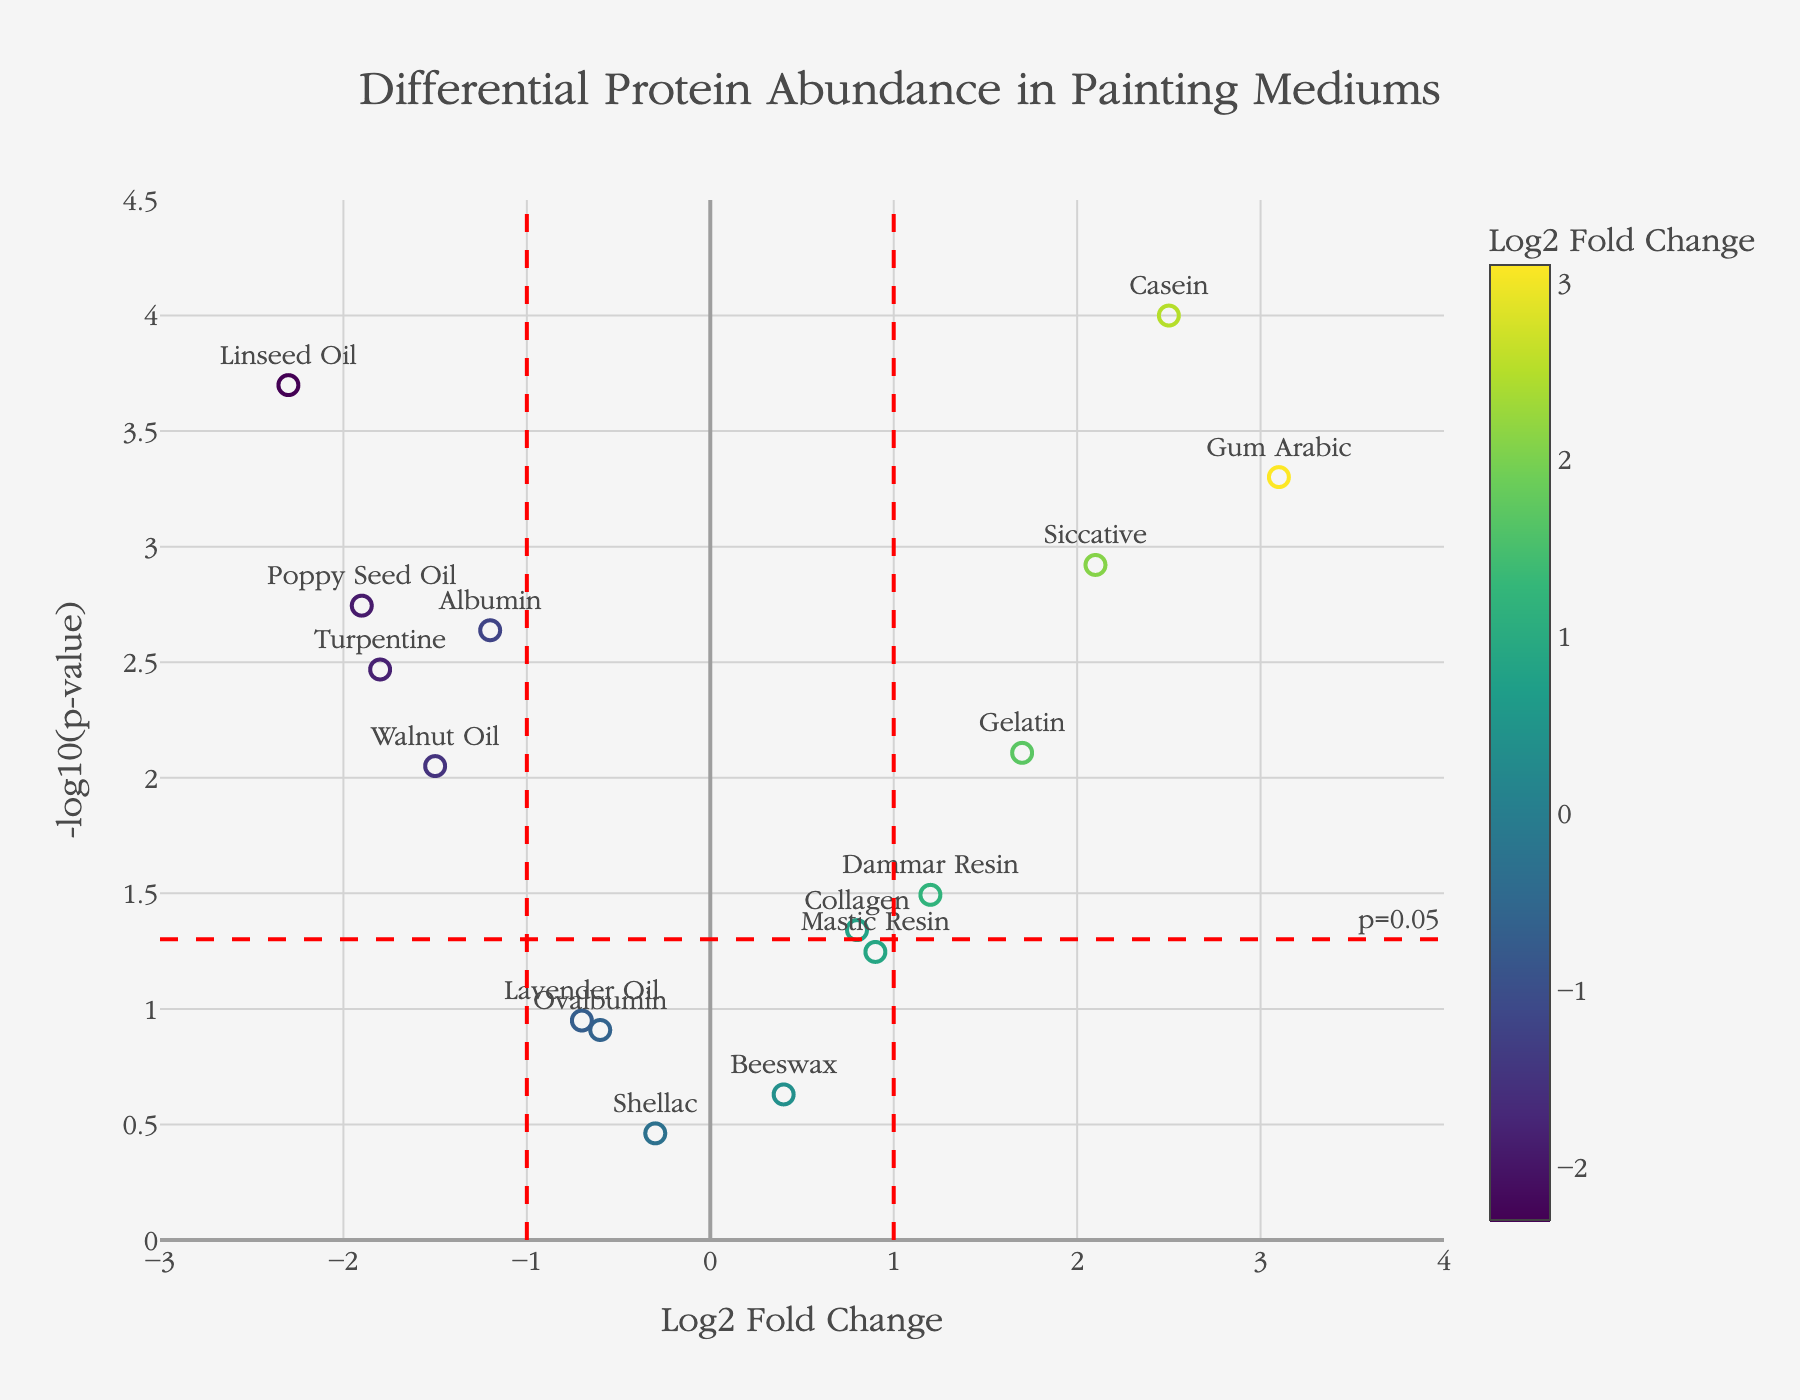What is the title of the figure? The title is typically placed prominently at the top of the figure. It provides a summary of what the plot is about. In this case, the title is "Differential Protein Abundance in Painting Mediums."
Answer: Differential Protein Abundance in Painting Mediums How many proteins have a Log2 Fold Change greater than 1? The figure plots Log2 Fold Change on the x-axis. By visually inspecting the plot, count the number of markers positioned to the right of the vertical line at Log2 Fold Change = 1. These markers represent proteins with Log2 Fold Change greater than 1.
Answer: 4 Which protein has the highest p-value? The y-axis shows -log10(p-value), so the protein corresponding to the lowest y-value will have the highest p-value. Identifying this marker and referring to its label will reveal the protein.
Answer: Shellac What does a p-value of 0.05 correspond to on the y-axis? In the context of -log10(p-value), a p-value of 0.05 can be calculated and is typically marked with a threshold line. -log10(0.05) equates to approximately 1.3. Therefore, the y-axis value at this threshold for p-value = 0.05 is 1.3.
Answer: 1.3 Which protein shows the most extreme differential abundance (highest absolute Log2 Fold Change)? The most extreme differential abundance would be represented by the marker farthest from zero on the x-axis. Here, the marker with the highest absolute value for Log2 Fold Change represents the protein with the most extreme differential abundance.
Answer: Gum Arabic How many proteins have statistically significant differential abundances (p-value < 0.05)? Proteins with p-values less than 0.05 will be plotted above the threshold horizontal line at y = 1.3. Count the markers above this line to determine how many fall into this category.
Answer: 11 Which protein has the lowest log2 fold change? The x-axis of the plot shows Log2 Fold Change. The protein with the lowest log2 fold change will be represented by the marker farthest to the left on this axis.
Answer: Linseed Oil Compare the p-values of Gelatin and Dammar Resin: which one is lower? Locate the markers for Gelatin and Dammar Resin by their text labels, then compare their y-axis positions. The one higher up on the plot has the lower p-value since the y-axis represents -log10(p-value).
Answer: Gelatin What is the Log2 Fold Change of Siccative, and is it statistically significant? Find the marker labeled for Siccative and check its position on the x-axis to get the Log2 Fold Change. Check if it is above the y = 1.3 horizontal line (indicating a p-value < 0.05) to determine statistical significance. Siccative's Log2 Fold Change is around 2.1 and it is above y = 1.3.
Answer: 2.1, Yes Which proteins fall within the range of Log2 Fold Change between -1 and 1 and have p-values less than 0.05? The proteins will be represented by markers between the two vertical lines at Log2 Fold Change = -1 and 1 and above the horizontal line at y = 1.3. Identify these markers to find the corresponding proteins.
Answer: Collagen, Dammar Resin 